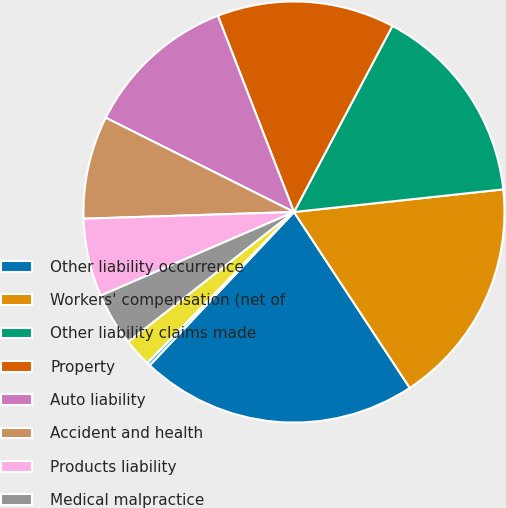Convert chart to OTSL. <chart><loc_0><loc_0><loc_500><loc_500><pie_chart><fcel>Other liability occurrence<fcel>Workers' compensation (net of<fcel>Other liability claims made<fcel>Property<fcel>Auto liability<fcel>Accident and health<fcel>Products liability<fcel>Medical malpractice<fcel>Aircraft<fcel>Mortgage guaranty / credit<nl><fcel>21.28%<fcel>17.45%<fcel>15.54%<fcel>13.63%<fcel>11.72%<fcel>7.9%<fcel>5.99%<fcel>4.08%<fcel>2.16%<fcel>0.25%<nl></chart> 